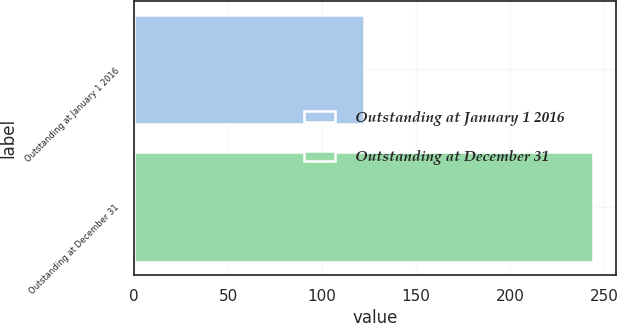Convert chart. <chart><loc_0><loc_0><loc_500><loc_500><bar_chart><fcel>Outstanding at January 1 2016<fcel>Outstanding at December 31<nl><fcel>122<fcel>244<nl></chart> 